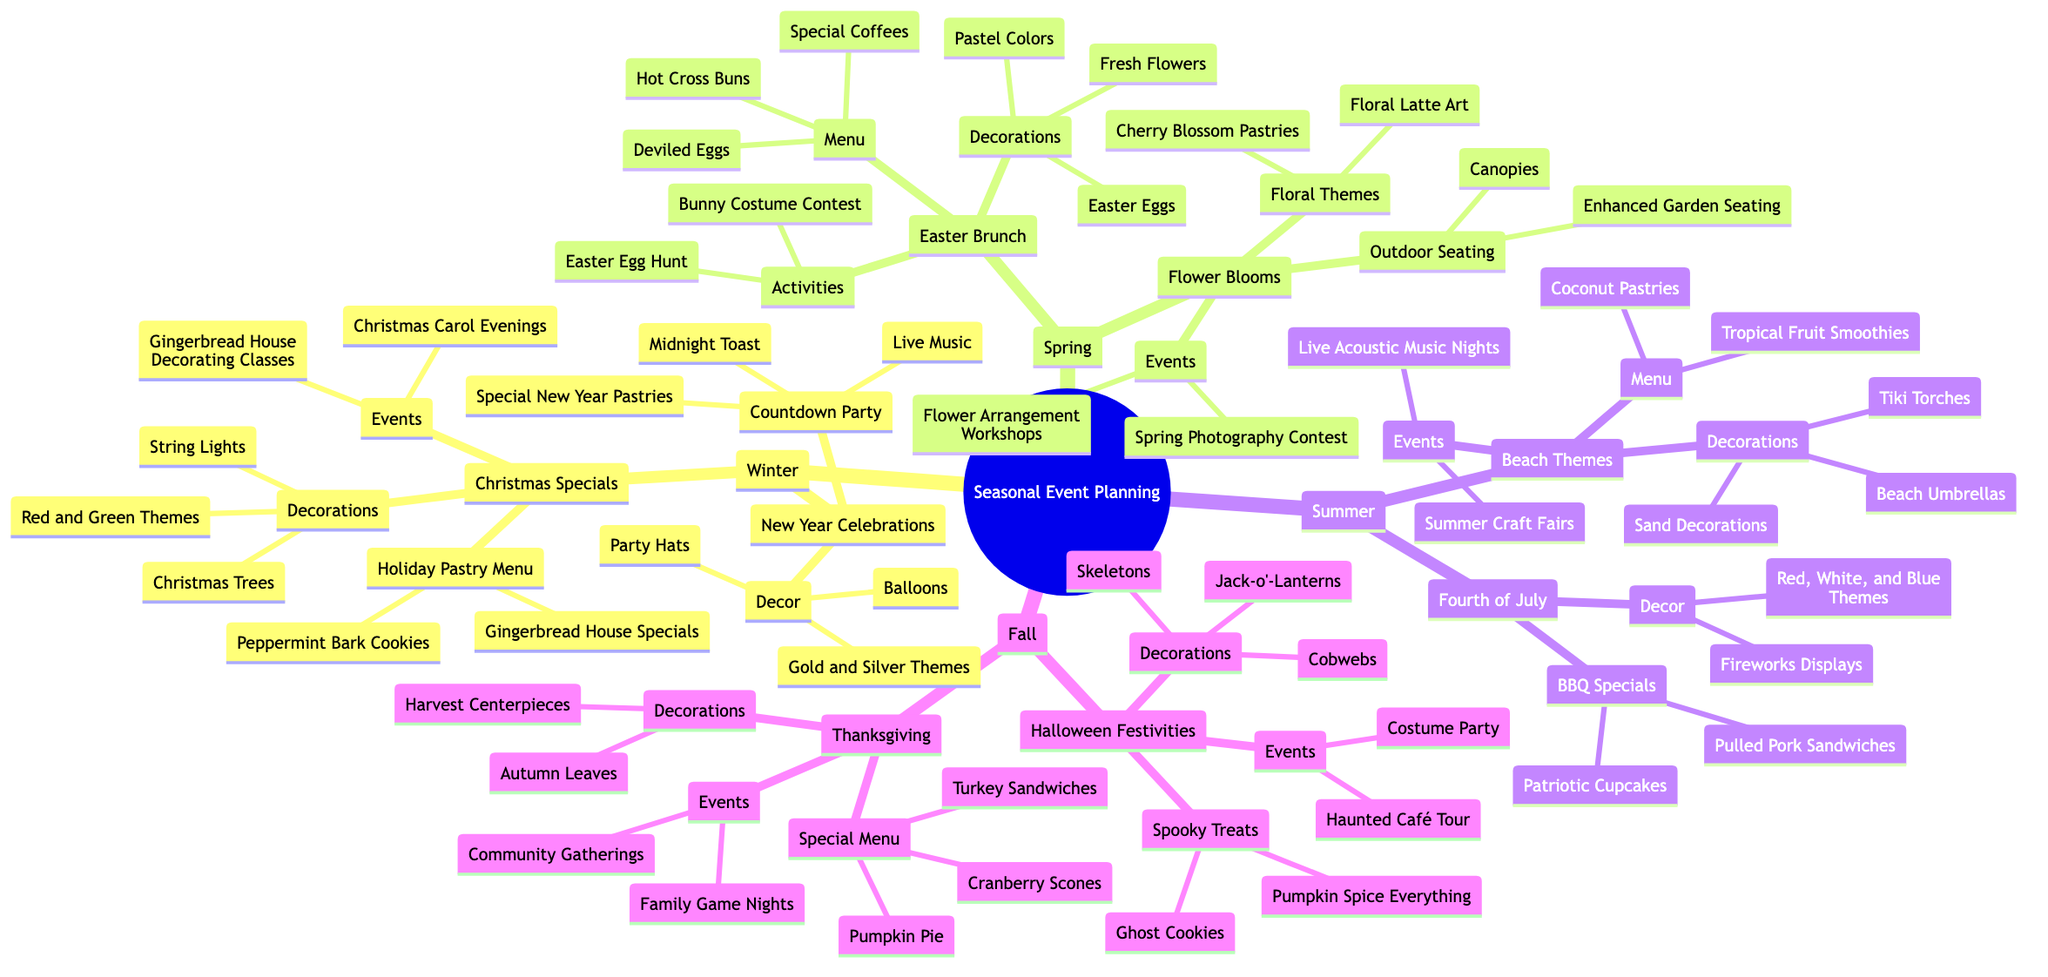What seasonal events are planned for Winter? The diagram shows two primary events for Winter: Christmas Specials and New Year Celebrations. These categories highlight the focus on festivities during this season.
Answer: Christmas Specials, New Year Celebrations How many activities are listed under Easter Brunch? Under the Easter Brunch category, there are two activities mentioned: Easter Egg Hunt and Bunny Costume Contest. Therefore, by counting the listed activities, we can determine the total.
Answer: 2 What is a unique decoration used for Halloween Festivities? In the Halloween Festivities section, one of the decorations is Jack-o'-Lanterns, which is a traditionally unique decoration associated with this event.
Answer: Jack-o'-Lanterns What menu item is featured for the Fourth of July? The Fourth of July category includes BBQ Specials featuring Pulled Pork Sandwiches. This specific menu item represents a highlight for this summer event.
Answer: Pulled Pork Sandwiches Which season features the Flower Arrangement Workshops? The Flower Arrangement Workshops are listed under the Flower Blooms event, which is part of the Spring season. This ties the workshop to a blossoming atmosphere and a celebration of spring.
Answer: Spring 